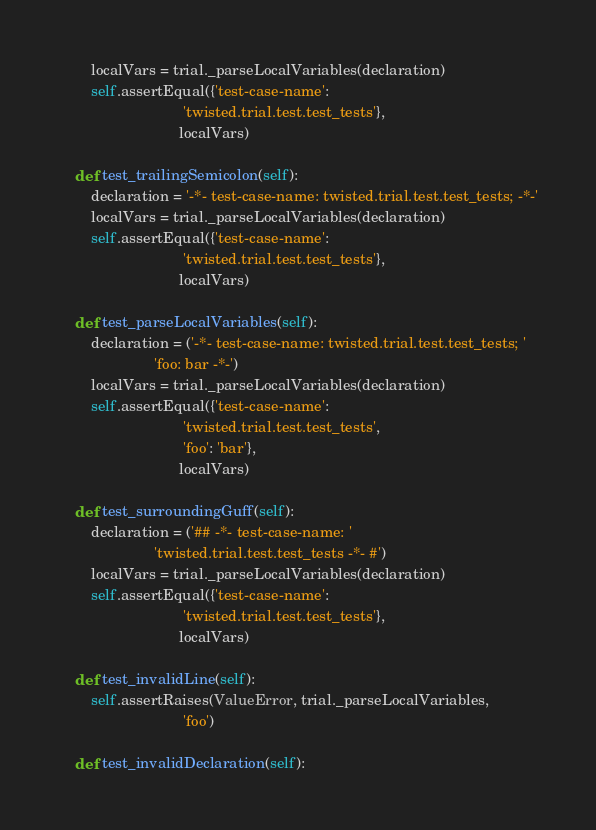<code> <loc_0><loc_0><loc_500><loc_500><_Python_>        localVars = trial._parseLocalVariables(declaration)
        self.assertEqual({'test-case-name':
                              'twisted.trial.test.test_tests'},
                             localVars)

    def test_trailingSemicolon(self):
        declaration = '-*- test-case-name: twisted.trial.test.test_tests; -*-'
        localVars = trial._parseLocalVariables(declaration)
        self.assertEqual({'test-case-name':
                              'twisted.trial.test.test_tests'},
                             localVars)

    def test_parseLocalVariables(self):
        declaration = ('-*- test-case-name: twisted.trial.test.test_tests; '
                       'foo: bar -*-')
        localVars = trial._parseLocalVariables(declaration)
        self.assertEqual({'test-case-name':
                              'twisted.trial.test.test_tests',
                              'foo': 'bar'},
                             localVars)

    def test_surroundingGuff(self):
        declaration = ('## -*- test-case-name: '
                       'twisted.trial.test.test_tests -*- #')
        localVars = trial._parseLocalVariables(declaration)
        self.assertEqual({'test-case-name':
                              'twisted.trial.test.test_tests'},
                             localVars)

    def test_invalidLine(self):
        self.assertRaises(ValueError, trial._parseLocalVariables,
                              'foo')

    def test_invalidDeclaration(self):</code> 